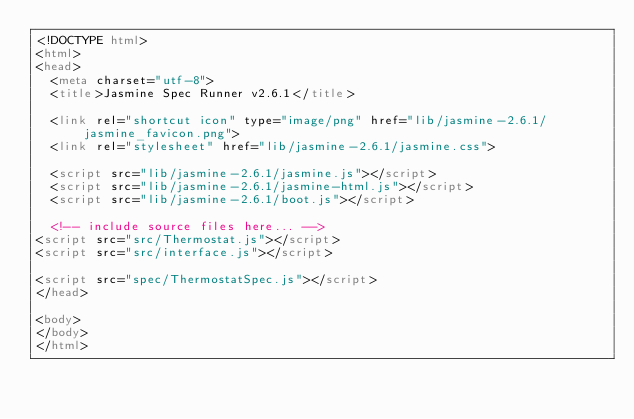Convert code to text. <code><loc_0><loc_0><loc_500><loc_500><_HTML_><!DOCTYPE html>
<html>
<head>
  <meta charset="utf-8">
  <title>Jasmine Spec Runner v2.6.1</title>

  <link rel="shortcut icon" type="image/png" href="lib/jasmine-2.6.1/jasmine_favicon.png">
  <link rel="stylesheet" href="lib/jasmine-2.6.1/jasmine.css">

  <script src="lib/jasmine-2.6.1/jasmine.js"></script>
  <script src="lib/jasmine-2.6.1/jasmine-html.js"></script>
  <script src="lib/jasmine-2.6.1/boot.js"></script>

  <!-- include source files here... -->
<script src="src/Thermostat.js"></script>
<script src="src/interface.js"></script>

<script src="spec/ThermostatSpec.js"></script>
</head>

<body>
</body>
</html>
</code> 